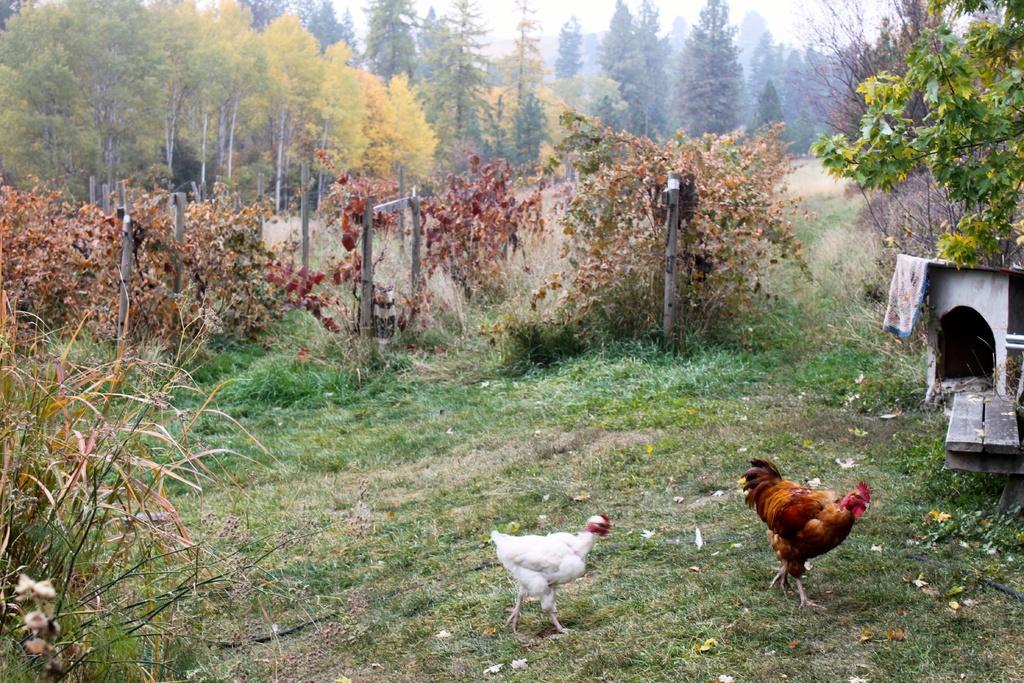How would you summarize this image in a sentence or two? In this image in the front there are birds on the ground. In the background they are trees. On the ground there is grass. On the right side there is a hut. 